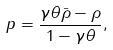<formula> <loc_0><loc_0><loc_500><loc_500>p = \frac { \gamma \theta \bar { \rho } - \rho } { 1 - \gamma \theta } ,</formula> 